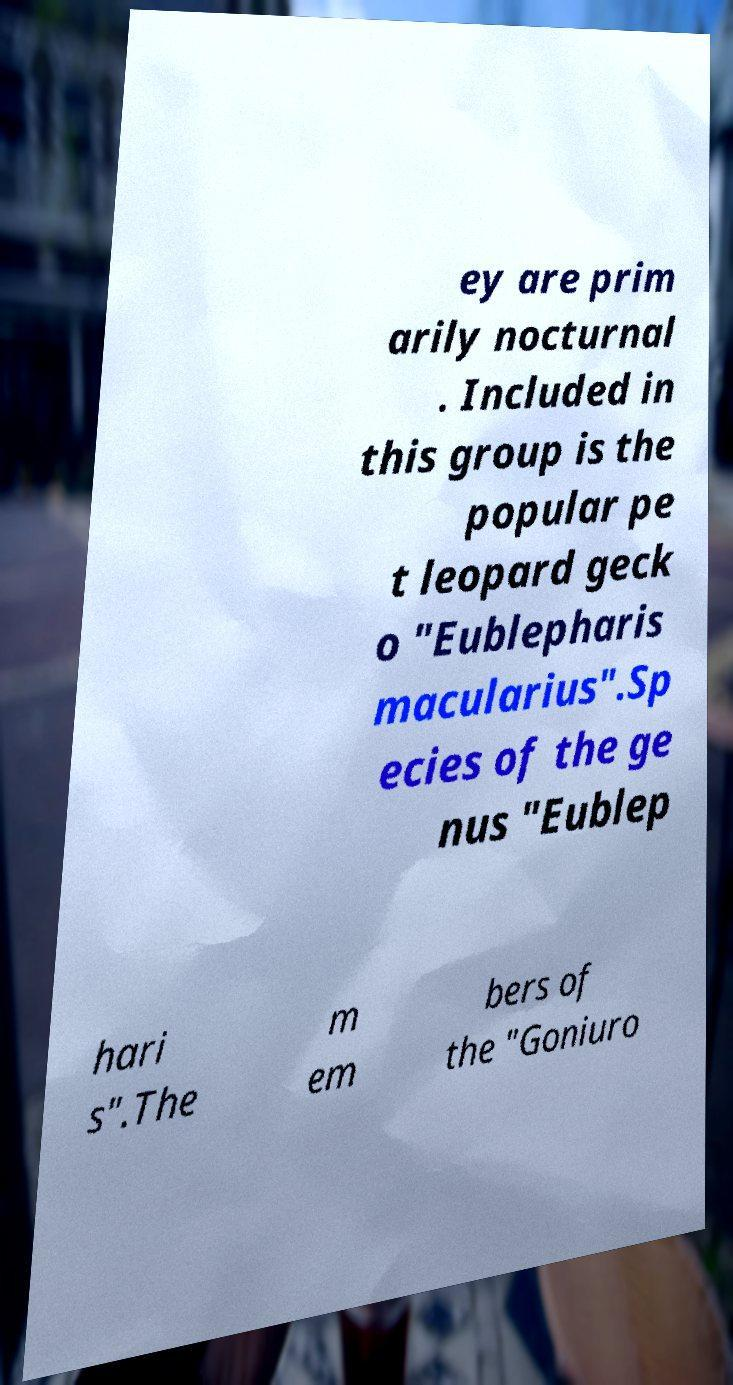Please identify and transcribe the text found in this image. ey are prim arily nocturnal . Included in this group is the popular pe t leopard geck o "Eublepharis macularius".Sp ecies of the ge nus "Eublep hari s".The m em bers of the "Goniuro 